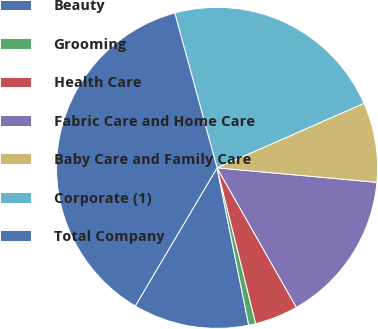Convert chart to OTSL. <chart><loc_0><loc_0><loc_500><loc_500><pie_chart><fcel>Beauty<fcel>Grooming<fcel>Health Care<fcel>Fabric Care and Home Care<fcel>Baby Care and Family Care<fcel>Corporate (1)<fcel>Total Company<nl><fcel>11.67%<fcel>0.71%<fcel>4.36%<fcel>15.33%<fcel>8.02%<fcel>22.66%<fcel>37.25%<nl></chart> 